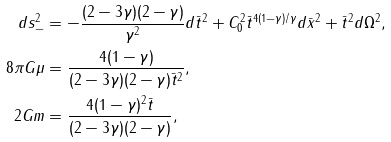Convert formula to latex. <formula><loc_0><loc_0><loc_500><loc_500>d s _ { - } ^ { 2 } & = - \frac { ( 2 - 3 \gamma ) ( 2 - \gamma ) } { \gamma ^ { 2 } } d { \bar { t } } ^ { 2 } + C _ { 0 } ^ { 2 } { \bar { t } } ^ { 4 ( 1 - \gamma ) / \gamma } d { \bar { x } } ^ { 2 } + { \bar { t } } ^ { 2 } d \Omega ^ { 2 } , \\ 8 \pi G \mu & = \frac { 4 ( 1 - \gamma ) } { ( 2 - 3 \gamma ) ( 2 - \gamma ) { \bar { t } } ^ { 2 } } , \\ 2 G m & = \frac { 4 ( 1 - \gamma ) ^ { 2 } { \bar { t } } } { ( 2 - 3 \gamma ) ( 2 - \gamma ) } ,</formula> 